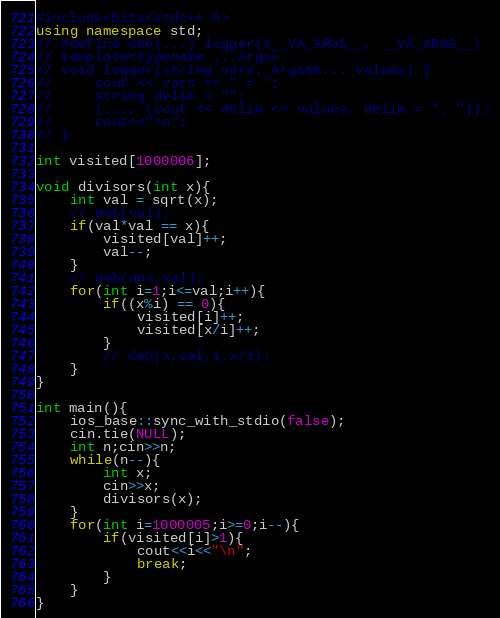<code> <loc_0><loc_0><loc_500><loc_500><_C++_>#include<bits/stdc++.h>
using namespace std;
// #define deb(...) logger(#__VA_ARGS__, __VA_ARGS__)
// template<typename ...Args>
// void logger(string vars, Args&&... values) {
//     cout << vars << " = ";
//     string delim = "";
//     (..., (cout << delim << values, delim = ", "));
//     cout<<"\n";
// }

int visited[1000006];

void divisors(int x){
    int val = sqrt(x);
    // deb(val);
    if(val*val == x){
        visited[val]++;
        val--;
    }
    // deb(ans,val);
    for(int i=1;i<=val;i++){
        if((x%i) == 0){
            visited[i]++;
            visited[x/i]++;
        }
        // deb(x,val,i,x/i);
    }
}

int main(){
    ios_base::sync_with_stdio(false);
    cin.tie(NULL);
    int n;cin>>n;
    while(n--){
        int x;
        cin>>x;
        divisors(x);
    }
    for(int i=1000005;i>=0;i--){
        if(visited[i]>1){
            cout<<i<<"\n";
            break;
        }
    }
}</code> 